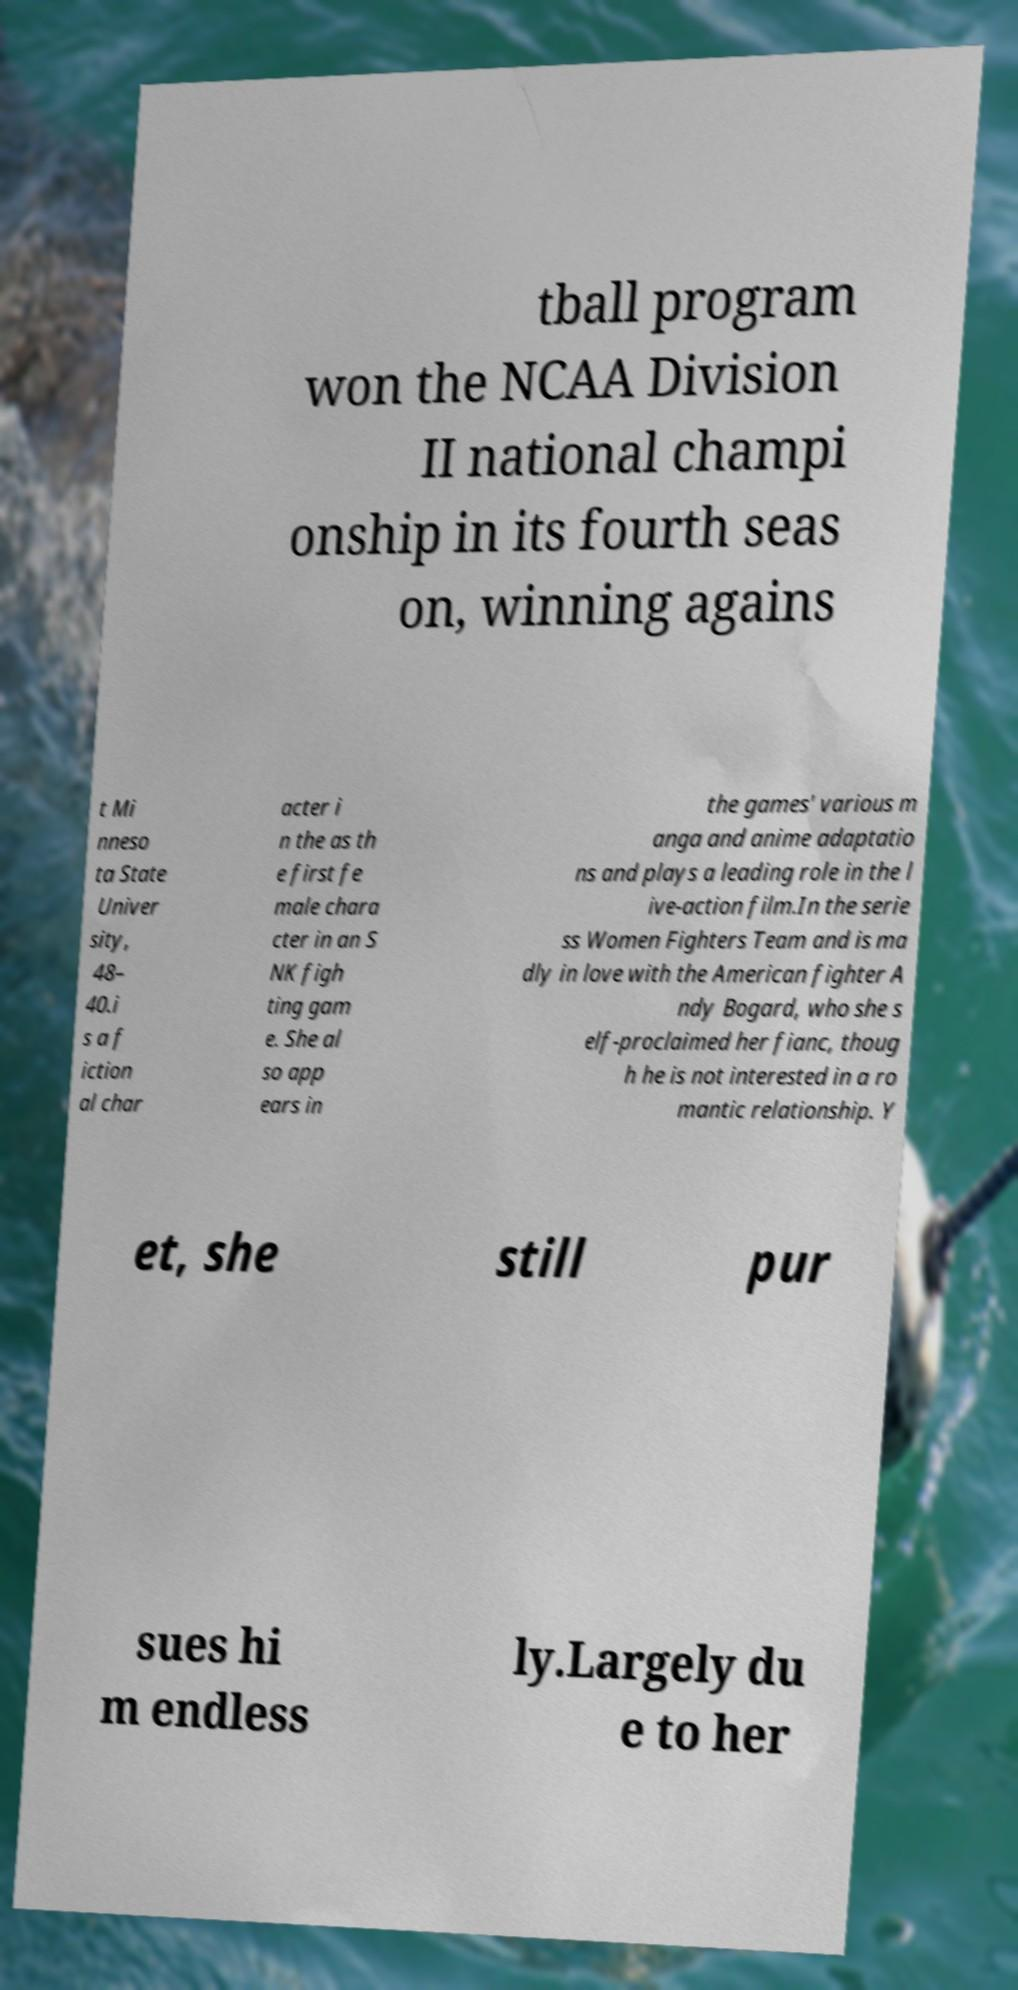Please read and relay the text visible in this image. What does it say? tball program won the NCAA Division II national champi onship in its fourth seas on, winning agains t Mi nneso ta State Univer sity, 48– 40.i s a f iction al char acter i n the as th e first fe male chara cter in an S NK figh ting gam e. She al so app ears in the games' various m anga and anime adaptatio ns and plays a leading role in the l ive-action film.In the serie ss Women Fighters Team and is ma dly in love with the American fighter A ndy Bogard, who she s elf-proclaimed her fianc, thoug h he is not interested in a ro mantic relationship. Y et, she still pur sues hi m endless ly.Largely du e to her 